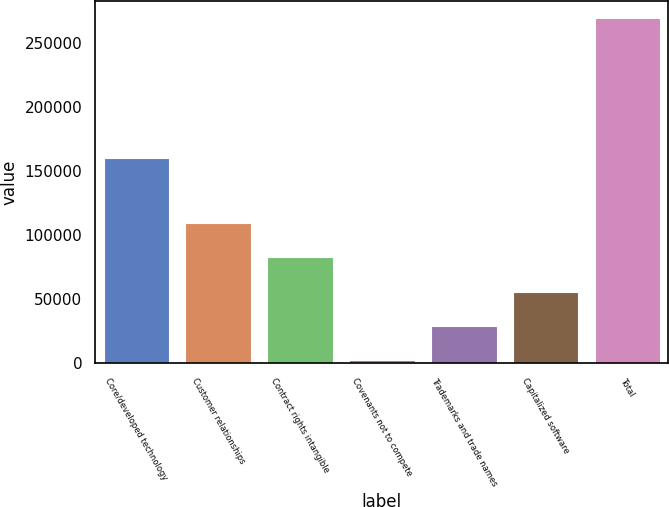Convert chart. <chart><loc_0><loc_0><loc_500><loc_500><bar_chart><fcel>Core/developed technology<fcel>Customer relationships<fcel>Contract rights intangible<fcel>Covenants not to compete<fcel>Trademarks and trade names<fcel>Capitalized software<fcel>Total<nl><fcel>159691<fcel>109014<fcel>82349<fcel>2354<fcel>29019<fcel>55684<fcel>269004<nl></chart> 